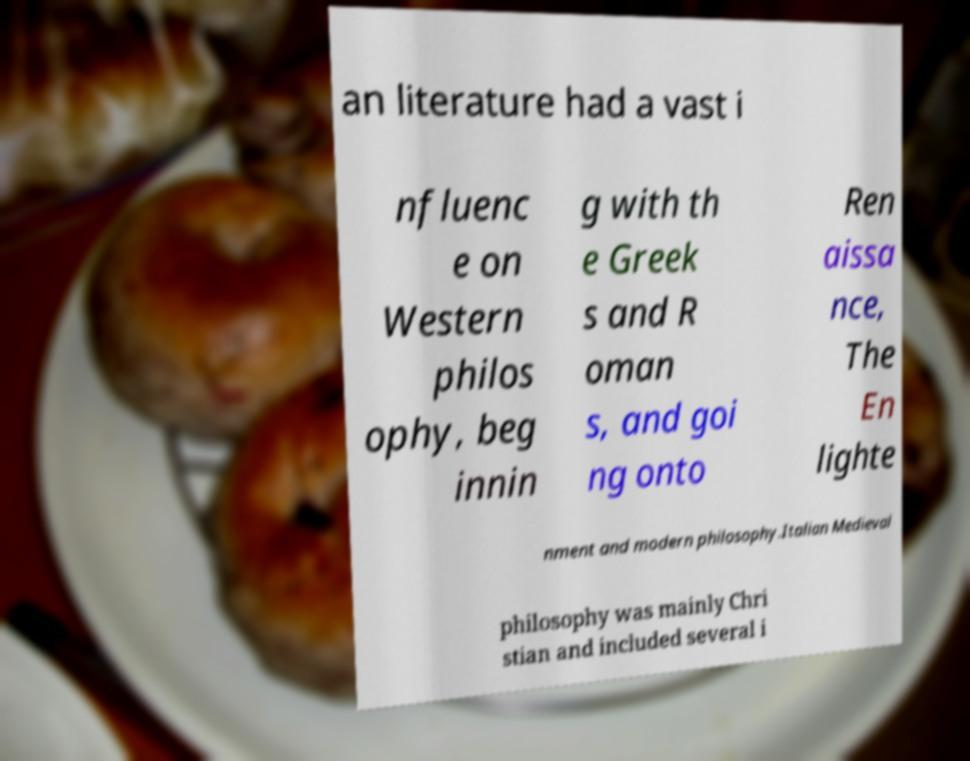There's text embedded in this image that I need extracted. Can you transcribe it verbatim? an literature had a vast i nfluenc e on Western philos ophy, beg innin g with th e Greek s and R oman s, and goi ng onto Ren aissa nce, The En lighte nment and modern philosophy.Italian Medieval philosophy was mainly Chri stian and included several i 